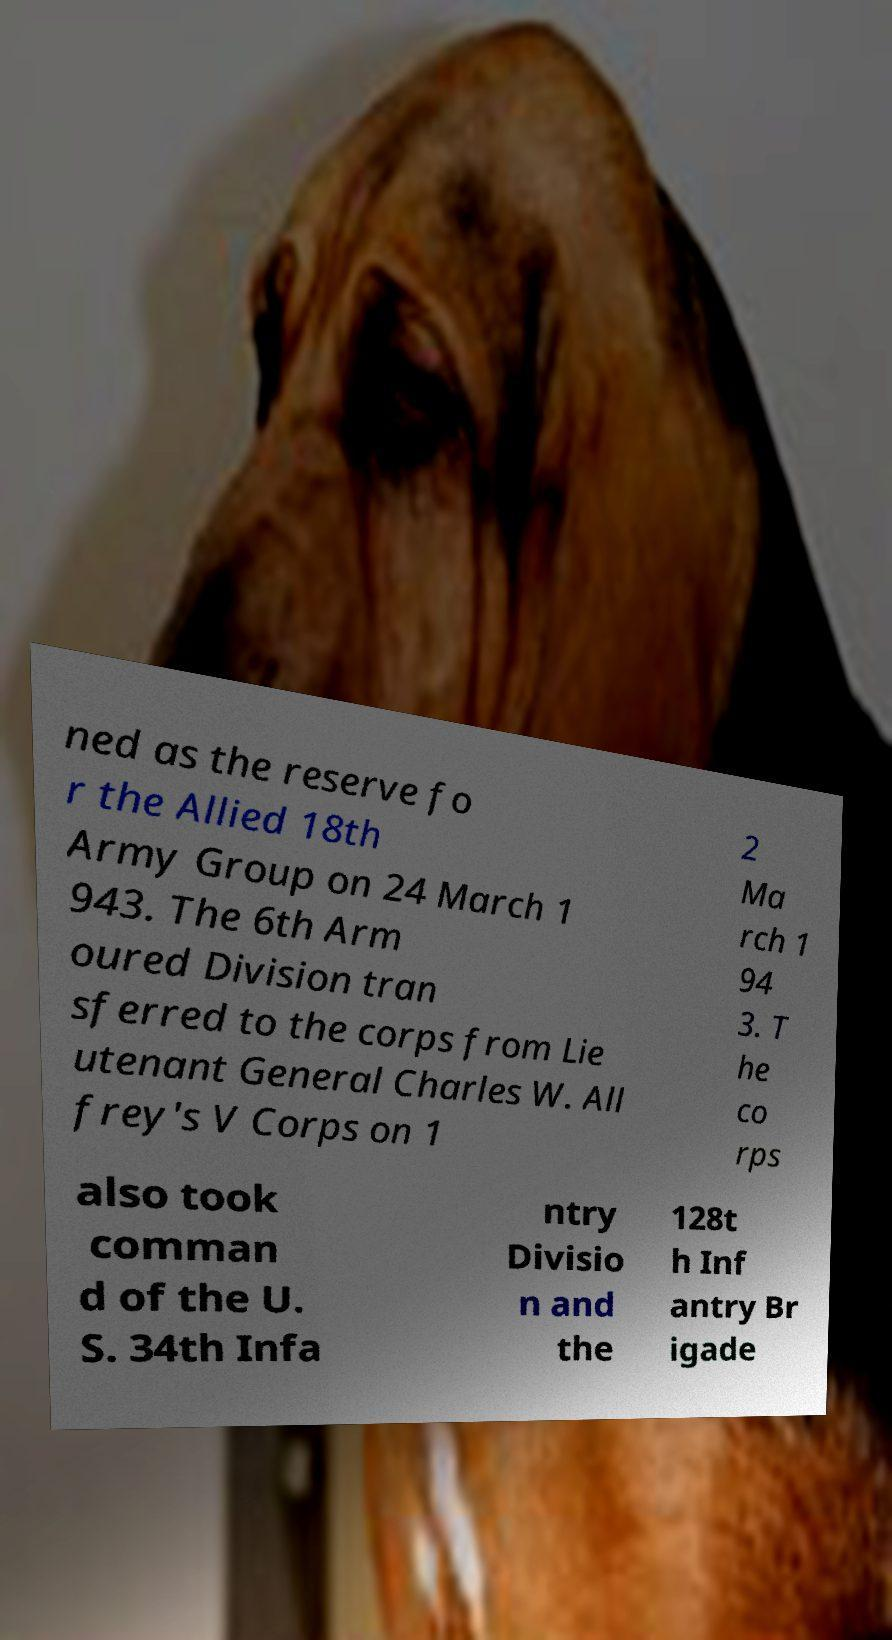Could you assist in decoding the text presented in this image and type it out clearly? ned as the reserve fo r the Allied 18th Army Group on 24 March 1 943. The 6th Arm oured Division tran sferred to the corps from Lie utenant General Charles W. All frey's V Corps on 1 2 Ma rch 1 94 3. T he co rps also took comman d of the U. S. 34th Infa ntry Divisio n and the 128t h Inf antry Br igade 